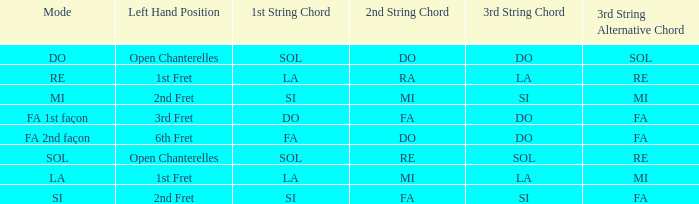For a 1st string of si Accord du and a 2nd string of mi what is the 3rd string? SI ou MI. 